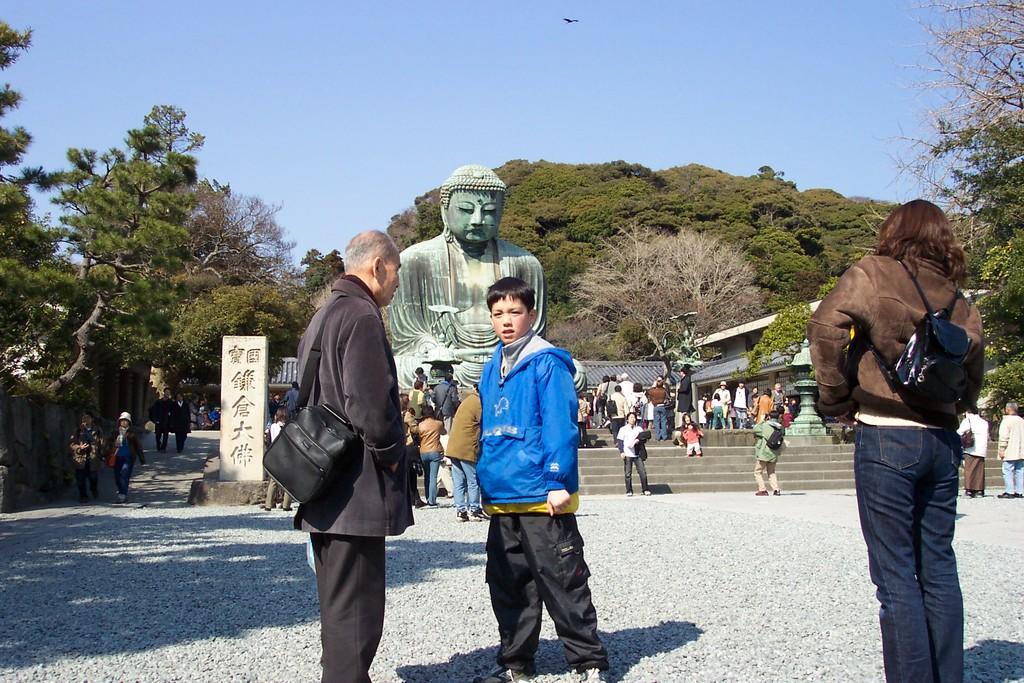How would you summarize this image in a sentence or two? In this image I can see number of people and I can see most of them are wearing jackets. I can also see few of them are carrying bags. I can also see shadows, stairs, number of trees, Buddha sculpture and here I can see something is written. I can also see the sky in background and here I can see a bird. 